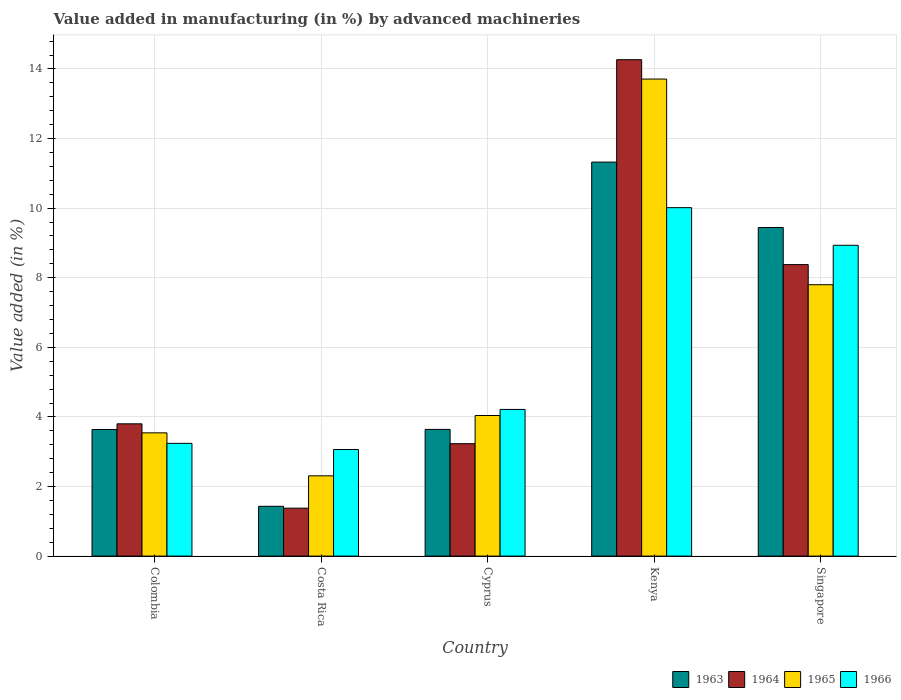How many different coloured bars are there?
Keep it short and to the point. 4. Are the number of bars per tick equal to the number of legend labels?
Offer a terse response. Yes. Are the number of bars on each tick of the X-axis equal?
Offer a very short reply. Yes. How many bars are there on the 1st tick from the left?
Your response must be concise. 4. How many bars are there on the 2nd tick from the right?
Offer a very short reply. 4. What is the label of the 1st group of bars from the left?
Offer a very short reply. Colombia. In how many cases, is the number of bars for a given country not equal to the number of legend labels?
Provide a short and direct response. 0. What is the percentage of value added in manufacturing by advanced machineries in 1964 in Cyprus?
Give a very brief answer. 3.23. Across all countries, what is the maximum percentage of value added in manufacturing by advanced machineries in 1963?
Provide a short and direct response. 11.32. Across all countries, what is the minimum percentage of value added in manufacturing by advanced machineries in 1964?
Make the answer very short. 1.38. In which country was the percentage of value added in manufacturing by advanced machineries in 1963 maximum?
Your response must be concise. Kenya. In which country was the percentage of value added in manufacturing by advanced machineries in 1965 minimum?
Your answer should be compact. Costa Rica. What is the total percentage of value added in manufacturing by advanced machineries in 1964 in the graph?
Provide a short and direct response. 31.05. What is the difference between the percentage of value added in manufacturing by advanced machineries in 1964 in Cyprus and that in Singapore?
Provide a succinct answer. -5.15. What is the difference between the percentage of value added in manufacturing by advanced machineries in 1964 in Kenya and the percentage of value added in manufacturing by advanced machineries in 1963 in Costa Rica?
Your answer should be very brief. 12.84. What is the average percentage of value added in manufacturing by advanced machineries in 1965 per country?
Keep it short and to the point. 6.28. What is the difference between the percentage of value added in manufacturing by advanced machineries of/in 1964 and percentage of value added in manufacturing by advanced machineries of/in 1963 in Costa Rica?
Ensure brevity in your answer.  -0.05. In how many countries, is the percentage of value added in manufacturing by advanced machineries in 1966 greater than 5.2 %?
Keep it short and to the point. 2. What is the ratio of the percentage of value added in manufacturing by advanced machineries in 1966 in Cyprus to that in Singapore?
Provide a short and direct response. 0.47. Is the percentage of value added in manufacturing by advanced machineries in 1963 in Colombia less than that in Cyprus?
Provide a short and direct response. Yes. What is the difference between the highest and the second highest percentage of value added in manufacturing by advanced machineries in 1965?
Offer a very short reply. -9.67. What is the difference between the highest and the lowest percentage of value added in manufacturing by advanced machineries in 1965?
Offer a very short reply. 11.4. In how many countries, is the percentage of value added in manufacturing by advanced machineries in 1966 greater than the average percentage of value added in manufacturing by advanced machineries in 1966 taken over all countries?
Ensure brevity in your answer.  2. Is the sum of the percentage of value added in manufacturing by advanced machineries in 1963 in Colombia and Costa Rica greater than the maximum percentage of value added in manufacturing by advanced machineries in 1965 across all countries?
Provide a succinct answer. No. What does the 3rd bar from the left in Costa Rica represents?
Provide a short and direct response. 1965. What does the 1st bar from the right in Costa Rica represents?
Provide a succinct answer. 1966. How many bars are there?
Make the answer very short. 20. How many countries are there in the graph?
Your answer should be very brief. 5. What is the difference between two consecutive major ticks on the Y-axis?
Provide a succinct answer. 2. Where does the legend appear in the graph?
Keep it short and to the point. Bottom right. How many legend labels are there?
Offer a very short reply. 4. How are the legend labels stacked?
Offer a terse response. Horizontal. What is the title of the graph?
Give a very brief answer. Value added in manufacturing (in %) by advanced machineries. Does "1970" appear as one of the legend labels in the graph?
Keep it short and to the point. No. What is the label or title of the Y-axis?
Offer a very short reply. Value added (in %). What is the Value added (in %) in 1963 in Colombia?
Your answer should be compact. 3.64. What is the Value added (in %) in 1964 in Colombia?
Provide a short and direct response. 3.8. What is the Value added (in %) in 1965 in Colombia?
Offer a terse response. 3.54. What is the Value added (in %) of 1966 in Colombia?
Your answer should be very brief. 3.24. What is the Value added (in %) in 1963 in Costa Rica?
Your answer should be compact. 1.43. What is the Value added (in %) in 1964 in Costa Rica?
Your answer should be compact. 1.38. What is the Value added (in %) of 1965 in Costa Rica?
Your response must be concise. 2.31. What is the Value added (in %) of 1966 in Costa Rica?
Your answer should be very brief. 3.06. What is the Value added (in %) of 1963 in Cyprus?
Provide a short and direct response. 3.64. What is the Value added (in %) in 1964 in Cyprus?
Your response must be concise. 3.23. What is the Value added (in %) in 1965 in Cyprus?
Provide a succinct answer. 4.04. What is the Value added (in %) of 1966 in Cyprus?
Keep it short and to the point. 4.22. What is the Value added (in %) of 1963 in Kenya?
Offer a very short reply. 11.32. What is the Value added (in %) of 1964 in Kenya?
Your response must be concise. 14.27. What is the Value added (in %) in 1965 in Kenya?
Provide a short and direct response. 13.71. What is the Value added (in %) of 1966 in Kenya?
Your answer should be very brief. 10.01. What is the Value added (in %) of 1963 in Singapore?
Provide a short and direct response. 9.44. What is the Value added (in %) of 1964 in Singapore?
Keep it short and to the point. 8.38. What is the Value added (in %) in 1965 in Singapore?
Keep it short and to the point. 7.8. What is the Value added (in %) of 1966 in Singapore?
Your answer should be very brief. 8.93. Across all countries, what is the maximum Value added (in %) in 1963?
Make the answer very short. 11.32. Across all countries, what is the maximum Value added (in %) in 1964?
Your response must be concise. 14.27. Across all countries, what is the maximum Value added (in %) of 1965?
Give a very brief answer. 13.71. Across all countries, what is the maximum Value added (in %) in 1966?
Your answer should be very brief. 10.01. Across all countries, what is the minimum Value added (in %) in 1963?
Your answer should be very brief. 1.43. Across all countries, what is the minimum Value added (in %) in 1964?
Your answer should be compact. 1.38. Across all countries, what is the minimum Value added (in %) in 1965?
Give a very brief answer. 2.31. Across all countries, what is the minimum Value added (in %) of 1966?
Offer a very short reply. 3.06. What is the total Value added (in %) in 1963 in the graph?
Provide a short and direct response. 29.48. What is the total Value added (in %) of 1964 in the graph?
Make the answer very short. 31.05. What is the total Value added (in %) of 1965 in the graph?
Ensure brevity in your answer.  31.4. What is the total Value added (in %) in 1966 in the graph?
Provide a succinct answer. 29.47. What is the difference between the Value added (in %) in 1963 in Colombia and that in Costa Rica?
Provide a short and direct response. 2.21. What is the difference between the Value added (in %) in 1964 in Colombia and that in Costa Rica?
Provide a short and direct response. 2.42. What is the difference between the Value added (in %) in 1965 in Colombia and that in Costa Rica?
Make the answer very short. 1.24. What is the difference between the Value added (in %) of 1966 in Colombia and that in Costa Rica?
Provide a succinct answer. 0.18. What is the difference between the Value added (in %) of 1963 in Colombia and that in Cyprus?
Offer a terse response. -0. What is the difference between the Value added (in %) of 1964 in Colombia and that in Cyprus?
Your answer should be compact. 0.57. What is the difference between the Value added (in %) in 1965 in Colombia and that in Cyprus?
Provide a succinct answer. -0.5. What is the difference between the Value added (in %) of 1966 in Colombia and that in Cyprus?
Ensure brevity in your answer.  -0.97. What is the difference between the Value added (in %) in 1963 in Colombia and that in Kenya?
Give a very brief answer. -7.69. What is the difference between the Value added (in %) of 1964 in Colombia and that in Kenya?
Your answer should be compact. -10.47. What is the difference between the Value added (in %) of 1965 in Colombia and that in Kenya?
Your response must be concise. -10.17. What is the difference between the Value added (in %) in 1966 in Colombia and that in Kenya?
Make the answer very short. -6.77. What is the difference between the Value added (in %) of 1963 in Colombia and that in Singapore?
Keep it short and to the point. -5.81. What is the difference between the Value added (in %) of 1964 in Colombia and that in Singapore?
Your answer should be compact. -4.58. What is the difference between the Value added (in %) in 1965 in Colombia and that in Singapore?
Offer a very short reply. -4.26. What is the difference between the Value added (in %) of 1966 in Colombia and that in Singapore?
Your response must be concise. -5.69. What is the difference between the Value added (in %) in 1963 in Costa Rica and that in Cyprus?
Make the answer very short. -2.21. What is the difference between the Value added (in %) in 1964 in Costa Rica and that in Cyprus?
Your answer should be very brief. -1.85. What is the difference between the Value added (in %) of 1965 in Costa Rica and that in Cyprus?
Ensure brevity in your answer.  -1.73. What is the difference between the Value added (in %) in 1966 in Costa Rica and that in Cyprus?
Provide a short and direct response. -1.15. What is the difference between the Value added (in %) of 1963 in Costa Rica and that in Kenya?
Offer a very short reply. -9.89. What is the difference between the Value added (in %) of 1964 in Costa Rica and that in Kenya?
Offer a terse response. -12.89. What is the difference between the Value added (in %) of 1965 in Costa Rica and that in Kenya?
Make the answer very short. -11.4. What is the difference between the Value added (in %) of 1966 in Costa Rica and that in Kenya?
Provide a succinct answer. -6.95. What is the difference between the Value added (in %) of 1963 in Costa Rica and that in Singapore?
Provide a succinct answer. -8.01. What is the difference between the Value added (in %) of 1964 in Costa Rica and that in Singapore?
Keep it short and to the point. -7. What is the difference between the Value added (in %) in 1965 in Costa Rica and that in Singapore?
Make the answer very short. -5.49. What is the difference between the Value added (in %) of 1966 in Costa Rica and that in Singapore?
Make the answer very short. -5.87. What is the difference between the Value added (in %) of 1963 in Cyprus and that in Kenya?
Make the answer very short. -7.68. What is the difference between the Value added (in %) in 1964 in Cyprus and that in Kenya?
Provide a short and direct response. -11.04. What is the difference between the Value added (in %) in 1965 in Cyprus and that in Kenya?
Give a very brief answer. -9.67. What is the difference between the Value added (in %) of 1966 in Cyprus and that in Kenya?
Offer a terse response. -5.8. What is the difference between the Value added (in %) in 1963 in Cyprus and that in Singapore?
Ensure brevity in your answer.  -5.8. What is the difference between the Value added (in %) of 1964 in Cyprus and that in Singapore?
Keep it short and to the point. -5.15. What is the difference between the Value added (in %) in 1965 in Cyprus and that in Singapore?
Ensure brevity in your answer.  -3.76. What is the difference between the Value added (in %) in 1966 in Cyprus and that in Singapore?
Keep it short and to the point. -4.72. What is the difference between the Value added (in %) in 1963 in Kenya and that in Singapore?
Offer a very short reply. 1.88. What is the difference between the Value added (in %) of 1964 in Kenya and that in Singapore?
Your response must be concise. 5.89. What is the difference between the Value added (in %) of 1965 in Kenya and that in Singapore?
Offer a terse response. 5.91. What is the difference between the Value added (in %) of 1966 in Kenya and that in Singapore?
Give a very brief answer. 1.08. What is the difference between the Value added (in %) in 1963 in Colombia and the Value added (in %) in 1964 in Costa Rica?
Keep it short and to the point. 2.26. What is the difference between the Value added (in %) in 1963 in Colombia and the Value added (in %) in 1965 in Costa Rica?
Provide a succinct answer. 1.33. What is the difference between the Value added (in %) in 1963 in Colombia and the Value added (in %) in 1966 in Costa Rica?
Your answer should be very brief. 0.57. What is the difference between the Value added (in %) in 1964 in Colombia and the Value added (in %) in 1965 in Costa Rica?
Offer a very short reply. 1.49. What is the difference between the Value added (in %) of 1964 in Colombia and the Value added (in %) of 1966 in Costa Rica?
Keep it short and to the point. 0.74. What is the difference between the Value added (in %) in 1965 in Colombia and the Value added (in %) in 1966 in Costa Rica?
Your answer should be compact. 0.48. What is the difference between the Value added (in %) in 1963 in Colombia and the Value added (in %) in 1964 in Cyprus?
Your response must be concise. 0.41. What is the difference between the Value added (in %) of 1963 in Colombia and the Value added (in %) of 1965 in Cyprus?
Your response must be concise. -0.4. What is the difference between the Value added (in %) of 1963 in Colombia and the Value added (in %) of 1966 in Cyprus?
Offer a very short reply. -0.58. What is the difference between the Value added (in %) of 1964 in Colombia and the Value added (in %) of 1965 in Cyprus?
Give a very brief answer. -0.24. What is the difference between the Value added (in %) in 1964 in Colombia and the Value added (in %) in 1966 in Cyprus?
Offer a very short reply. -0.41. What is the difference between the Value added (in %) of 1965 in Colombia and the Value added (in %) of 1966 in Cyprus?
Make the answer very short. -0.67. What is the difference between the Value added (in %) of 1963 in Colombia and the Value added (in %) of 1964 in Kenya?
Keep it short and to the point. -10.63. What is the difference between the Value added (in %) in 1963 in Colombia and the Value added (in %) in 1965 in Kenya?
Provide a short and direct response. -10.07. What is the difference between the Value added (in %) in 1963 in Colombia and the Value added (in %) in 1966 in Kenya?
Give a very brief answer. -6.38. What is the difference between the Value added (in %) of 1964 in Colombia and the Value added (in %) of 1965 in Kenya?
Make the answer very short. -9.91. What is the difference between the Value added (in %) in 1964 in Colombia and the Value added (in %) in 1966 in Kenya?
Provide a succinct answer. -6.21. What is the difference between the Value added (in %) of 1965 in Colombia and the Value added (in %) of 1966 in Kenya?
Your answer should be very brief. -6.47. What is the difference between the Value added (in %) in 1963 in Colombia and the Value added (in %) in 1964 in Singapore?
Keep it short and to the point. -4.74. What is the difference between the Value added (in %) in 1963 in Colombia and the Value added (in %) in 1965 in Singapore?
Your answer should be compact. -4.16. What is the difference between the Value added (in %) in 1963 in Colombia and the Value added (in %) in 1966 in Singapore?
Provide a short and direct response. -5.29. What is the difference between the Value added (in %) in 1964 in Colombia and the Value added (in %) in 1965 in Singapore?
Keep it short and to the point. -4. What is the difference between the Value added (in %) of 1964 in Colombia and the Value added (in %) of 1966 in Singapore?
Your answer should be very brief. -5.13. What is the difference between the Value added (in %) in 1965 in Colombia and the Value added (in %) in 1966 in Singapore?
Your response must be concise. -5.39. What is the difference between the Value added (in %) in 1963 in Costa Rica and the Value added (in %) in 1964 in Cyprus?
Provide a short and direct response. -1.8. What is the difference between the Value added (in %) of 1963 in Costa Rica and the Value added (in %) of 1965 in Cyprus?
Offer a terse response. -2.61. What is the difference between the Value added (in %) in 1963 in Costa Rica and the Value added (in %) in 1966 in Cyprus?
Provide a succinct answer. -2.78. What is the difference between the Value added (in %) of 1964 in Costa Rica and the Value added (in %) of 1965 in Cyprus?
Make the answer very short. -2.66. What is the difference between the Value added (in %) in 1964 in Costa Rica and the Value added (in %) in 1966 in Cyprus?
Make the answer very short. -2.84. What is the difference between the Value added (in %) of 1965 in Costa Rica and the Value added (in %) of 1966 in Cyprus?
Offer a terse response. -1.91. What is the difference between the Value added (in %) in 1963 in Costa Rica and the Value added (in %) in 1964 in Kenya?
Your response must be concise. -12.84. What is the difference between the Value added (in %) in 1963 in Costa Rica and the Value added (in %) in 1965 in Kenya?
Provide a short and direct response. -12.28. What is the difference between the Value added (in %) in 1963 in Costa Rica and the Value added (in %) in 1966 in Kenya?
Provide a short and direct response. -8.58. What is the difference between the Value added (in %) in 1964 in Costa Rica and the Value added (in %) in 1965 in Kenya?
Offer a very short reply. -12.33. What is the difference between the Value added (in %) of 1964 in Costa Rica and the Value added (in %) of 1966 in Kenya?
Give a very brief answer. -8.64. What is the difference between the Value added (in %) in 1965 in Costa Rica and the Value added (in %) in 1966 in Kenya?
Make the answer very short. -7.71. What is the difference between the Value added (in %) of 1963 in Costa Rica and the Value added (in %) of 1964 in Singapore?
Your response must be concise. -6.95. What is the difference between the Value added (in %) in 1963 in Costa Rica and the Value added (in %) in 1965 in Singapore?
Ensure brevity in your answer.  -6.37. What is the difference between the Value added (in %) of 1963 in Costa Rica and the Value added (in %) of 1966 in Singapore?
Keep it short and to the point. -7.5. What is the difference between the Value added (in %) of 1964 in Costa Rica and the Value added (in %) of 1965 in Singapore?
Offer a terse response. -6.42. What is the difference between the Value added (in %) of 1964 in Costa Rica and the Value added (in %) of 1966 in Singapore?
Your response must be concise. -7.55. What is the difference between the Value added (in %) of 1965 in Costa Rica and the Value added (in %) of 1966 in Singapore?
Offer a very short reply. -6.63. What is the difference between the Value added (in %) of 1963 in Cyprus and the Value added (in %) of 1964 in Kenya?
Offer a terse response. -10.63. What is the difference between the Value added (in %) of 1963 in Cyprus and the Value added (in %) of 1965 in Kenya?
Your answer should be compact. -10.07. What is the difference between the Value added (in %) of 1963 in Cyprus and the Value added (in %) of 1966 in Kenya?
Offer a very short reply. -6.37. What is the difference between the Value added (in %) in 1964 in Cyprus and the Value added (in %) in 1965 in Kenya?
Provide a short and direct response. -10.48. What is the difference between the Value added (in %) in 1964 in Cyprus and the Value added (in %) in 1966 in Kenya?
Your response must be concise. -6.78. What is the difference between the Value added (in %) in 1965 in Cyprus and the Value added (in %) in 1966 in Kenya?
Keep it short and to the point. -5.97. What is the difference between the Value added (in %) in 1963 in Cyprus and the Value added (in %) in 1964 in Singapore?
Provide a short and direct response. -4.74. What is the difference between the Value added (in %) of 1963 in Cyprus and the Value added (in %) of 1965 in Singapore?
Offer a very short reply. -4.16. What is the difference between the Value added (in %) of 1963 in Cyprus and the Value added (in %) of 1966 in Singapore?
Offer a very short reply. -5.29. What is the difference between the Value added (in %) in 1964 in Cyprus and the Value added (in %) in 1965 in Singapore?
Provide a short and direct response. -4.57. What is the difference between the Value added (in %) in 1964 in Cyprus and the Value added (in %) in 1966 in Singapore?
Your answer should be compact. -5.7. What is the difference between the Value added (in %) of 1965 in Cyprus and the Value added (in %) of 1966 in Singapore?
Keep it short and to the point. -4.89. What is the difference between the Value added (in %) of 1963 in Kenya and the Value added (in %) of 1964 in Singapore?
Keep it short and to the point. 2.95. What is the difference between the Value added (in %) of 1963 in Kenya and the Value added (in %) of 1965 in Singapore?
Offer a very short reply. 3.52. What is the difference between the Value added (in %) of 1963 in Kenya and the Value added (in %) of 1966 in Singapore?
Offer a very short reply. 2.39. What is the difference between the Value added (in %) in 1964 in Kenya and the Value added (in %) in 1965 in Singapore?
Keep it short and to the point. 6.47. What is the difference between the Value added (in %) of 1964 in Kenya and the Value added (in %) of 1966 in Singapore?
Ensure brevity in your answer.  5.33. What is the difference between the Value added (in %) in 1965 in Kenya and the Value added (in %) in 1966 in Singapore?
Your answer should be compact. 4.78. What is the average Value added (in %) of 1963 per country?
Give a very brief answer. 5.9. What is the average Value added (in %) of 1964 per country?
Offer a very short reply. 6.21. What is the average Value added (in %) of 1965 per country?
Give a very brief answer. 6.28. What is the average Value added (in %) in 1966 per country?
Give a very brief answer. 5.89. What is the difference between the Value added (in %) in 1963 and Value added (in %) in 1964 in Colombia?
Your answer should be very brief. -0.16. What is the difference between the Value added (in %) in 1963 and Value added (in %) in 1965 in Colombia?
Keep it short and to the point. 0.1. What is the difference between the Value added (in %) in 1963 and Value added (in %) in 1966 in Colombia?
Provide a succinct answer. 0.4. What is the difference between the Value added (in %) in 1964 and Value added (in %) in 1965 in Colombia?
Ensure brevity in your answer.  0.26. What is the difference between the Value added (in %) of 1964 and Value added (in %) of 1966 in Colombia?
Offer a terse response. 0.56. What is the difference between the Value added (in %) of 1965 and Value added (in %) of 1966 in Colombia?
Provide a short and direct response. 0.3. What is the difference between the Value added (in %) of 1963 and Value added (in %) of 1964 in Costa Rica?
Provide a succinct answer. 0.05. What is the difference between the Value added (in %) of 1963 and Value added (in %) of 1965 in Costa Rica?
Provide a succinct answer. -0.88. What is the difference between the Value added (in %) of 1963 and Value added (in %) of 1966 in Costa Rica?
Provide a short and direct response. -1.63. What is the difference between the Value added (in %) of 1964 and Value added (in %) of 1965 in Costa Rica?
Your response must be concise. -0.93. What is the difference between the Value added (in %) in 1964 and Value added (in %) in 1966 in Costa Rica?
Your answer should be very brief. -1.69. What is the difference between the Value added (in %) in 1965 and Value added (in %) in 1966 in Costa Rica?
Make the answer very short. -0.76. What is the difference between the Value added (in %) in 1963 and Value added (in %) in 1964 in Cyprus?
Make the answer very short. 0.41. What is the difference between the Value added (in %) in 1963 and Value added (in %) in 1965 in Cyprus?
Make the answer very short. -0.4. What is the difference between the Value added (in %) of 1963 and Value added (in %) of 1966 in Cyprus?
Provide a short and direct response. -0.57. What is the difference between the Value added (in %) in 1964 and Value added (in %) in 1965 in Cyprus?
Keep it short and to the point. -0.81. What is the difference between the Value added (in %) of 1964 and Value added (in %) of 1966 in Cyprus?
Offer a terse response. -0.98. What is the difference between the Value added (in %) in 1965 and Value added (in %) in 1966 in Cyprus?
Your answer should be compact. -0.17. What is the difference between the Value added (in %) in 1963 and Value added (in %) in 1964 in Kenya?
Ensure brevity in your answer.  -2.94. What is the difference between the Value added (in %) in 1963 and Value added (in %) in 1965 in Kenya?
Your answer should be very brief. -2.39. What is the difference between the Value added (in %) of 1963 and Value added (in %) of 1966 in Kenya?
Your answer should be compact. 1.31. What is the difference between the Value added (in %) in 1964 and Value added (in %) in 1965 in Kenya?
Give a very brief answer. 0.56. What is the difference between the Value added (in %) in 1964 and Value added (in %) in 1966 in Kenya?
Your answer should be compact. 4.25. What is the difference between the Value added (in %) in 1965 and Value added (in %) in 1966 in Kenya?
Your answer should be very brief. 3.7. What is the difference between the Value added (in %) of 1963 and Value added (in %) of 1964 in Singapore?
Your answer should be compact. 1.07. What is the difference between the Value added (in %) of 1963 and Value added (in %) of 1965 in Singapore?
Keep it short and to the point. 1.64. What is the difference between the Value added (in %) in 1963 and Value added (in %) in 1966 in Singapore?
Your answer should be very brief. 0.51. What is the difference between the Value added (in %) in 1964 and Value added (in %) in 1965 in Singapore?
Provide a short and direct response. 0.58. What is the difference between the Value added (in %) of 1964 and Value added (in %) of 1966 in Singapore?
Provide a succinct answer. -0.55. What is the difference between the Value added (in %) in 1965 and Value added (in %) in 1966 in Singapore?
Offer a terse response. -1.13. What is the ratio of the Value added (in %) in 1963 in Colombia to that in Costa Rica?
Your answer should be very brief. 2.54. What is the ratio of the Value added (in %) of 1964 in Colombia to that in Costa Rica?
Provide a short and direct response. 2.76. What is the ratio of the Value added (in %) of 1965 in Colombia to that in Costa Rica?
Your answer should be very brief. 1.54. What is the ratio of the Value added (in %) of 1966 in Colombia to that in Costa Rica?
Make the answer very short. 1.06. What is the ratio of the Value added (in %) in 1964 in Colombia to that in Cyprus?
Provide a succinct answer. 1.18. What is the ratio of the Value added (in %) in 1965 in Colombia to that in Cyprus?
Offer a very short reply. 0.88. What is the ratio of the Value added (in %) in 1966 in Colombia to that in Cyprus?
Provide a succinct answer. 0.77. What is the ratio of the Value added (in %) of 1963 in Colombia to that in Kenya?
Offer a terse response. 0.32. What is the ratio of the Value added (in %) of 1964 in Colombia to that in Kenya?
Ensure brevity in your answer.  0.27. What is the ratio of the Value added (in %) of 1965 in Colombia to that in Kenya?
Keep it short and to the point. 0.26. What is the ratio of the Value added (in %) of 1966 in Colombia to that in Kenya?
Ensure brevity in your answer.  0.32. What is the ratio of the Value added (in %) in 1963 in Colombia to that in Singapore?
Keep it short and to the point. 0.39. What is the ratio of the Value added (in %) in 1964 in Colombia to that in Singapore?
Offer a terse response. 0.45. What is the ratio of the Value added (in %) in 1965 in Colombia to that in Singapore?
Give a very brief answer. 0.45. What is the ratio of the Value added (in %) of 1966 in Colombia to that in Singapore?
Your answer should be very brief. 0.36. What is the ratio of the Value added (in %) of 1963 in Costa Rica to that in Cyprus?
Provide a short and direct response. 0.39. What is the ratio of the Value added (in %) of 1964 in Costa Rica to that in Cyprus?
Make the answer very short. 0.43. What is the ratio of the Value added (in %) of 1965 in Costa Rica to that in Cyprus?
Ensure brevity in your answer.  0.57. What is the ratio of the Value added (in %) in 1966 in Costa Rica to that in Cyprus?
Your answer should be very brief. 0.73. What is the ratio of the Value added (in %) of 1963 in Costa Rica to that in Kenya?
Offer a very short reply. 0.13. What is the ratio of the Value added (in %) in 1964 in Costa Rica to that in Kenya?
Your answer should be compact. 0.1. What is the ratio of the Value added (in %) of 1965 in Costa Rica to that in Kenya?
Your answer should be compact. 0.17. What is the ratio of the Value added (in %) of 1966 in Costa Rica to that in Kenya?
Offer a terse response. 0.31. What is the ratio of the Value added (in %) in 1963 in Costa Rica to that in Singapore?
Your response must be concise. 0.15. What is the ratio of the Value added (in %) of 1964 in Costa Rica to that in Singapore?
Give a very brief answer. 0.16. What is the ratio of the Value added (in %) of 1965 in Costa Rica to that in Singapore?
Offer a very short reply. 0.3. What is the ratio of the Value added (in %) in 1966 in Costa Rica to that in Singapore?
Your answer should be very brief. 0.34. What is the ratio of the Value added (in %) of 1963 in Cyprus to that in Kenya?
Give a very brief answer. 0.32. What is the ratio of the Value added (in %) of 1964 in Cyprus to that in Kenya?
Provide a short and direct response. 0.23. What is the ratio of the Value added (in %) in 1965 in Cyprus to that in Kenya?
Ensure brevity in your answer.  0.29. What is the ratio of the Value added (in %) in 1966 in Cyprus to that in Kenya?
Keep it short and to the point. 0.42. What is the ratio of the Value added (in %) in 1963 in Cyprus to that in Singapore?
Make the answer very short. 0.39. What is the ratio of the Value added (in %) in 1964 in Cyprus to that in Singapore?
Your response must be concise. 0.39. What is the ratio of the Value added (in %) of 1965 in Cyprus to that in Singapore?
Provide a succinct answer. 0.52. What is the ratio of the Value added (in %) of 1966 in Cyprus to that in Singapore?
Your answer should be very brief. 0.47. What is the ratio of the Value added (in %) in 1963 in Kenya to that in Singapore?
Offer a terse response. 1.2. What is the ratio of the Value added (in %) in 1964 in Kenya to that in Singapore?
Your response must be concise. 1.7. What is the ratio of the Value added (in %) in 1965 in Kenya to that in Singapore?
Offer a terse response. 1.76. What is the ratio of the Value added (in %) of 1966 in Kenya to that in Singapore?
Offer a very short reply. 1.12. What is the difference between the highest and the second highest Value added (in %) in 1963?
Offer a terse response. 1.88. What is the difference between the highest and the second highest Value added (in %) of 1964?
Your answer should be compact. 5.89. What is the difference between the highest and the second highest Value added (in %) in 1965?
Make the answer very short. 5.91. What is the difference between the highest and the second highest Value added (in %) of 1966?
Offer a very short reply. 1.08. What is the difference between the highest and the lowest Value added (in %) of 1963?
Your response must be concise. 9.89. What is the difference between the highest and the lowest Value added (in %) of 1964?
Offer a terse response. 12.89. What is the difference between the highest and the lowest Value added (in %) in 1965?
Your response must be concise. 11.4. What is the difference between the highest and the lowest Value added (in %) of 1966?
Offer a terse response. 6.95. 